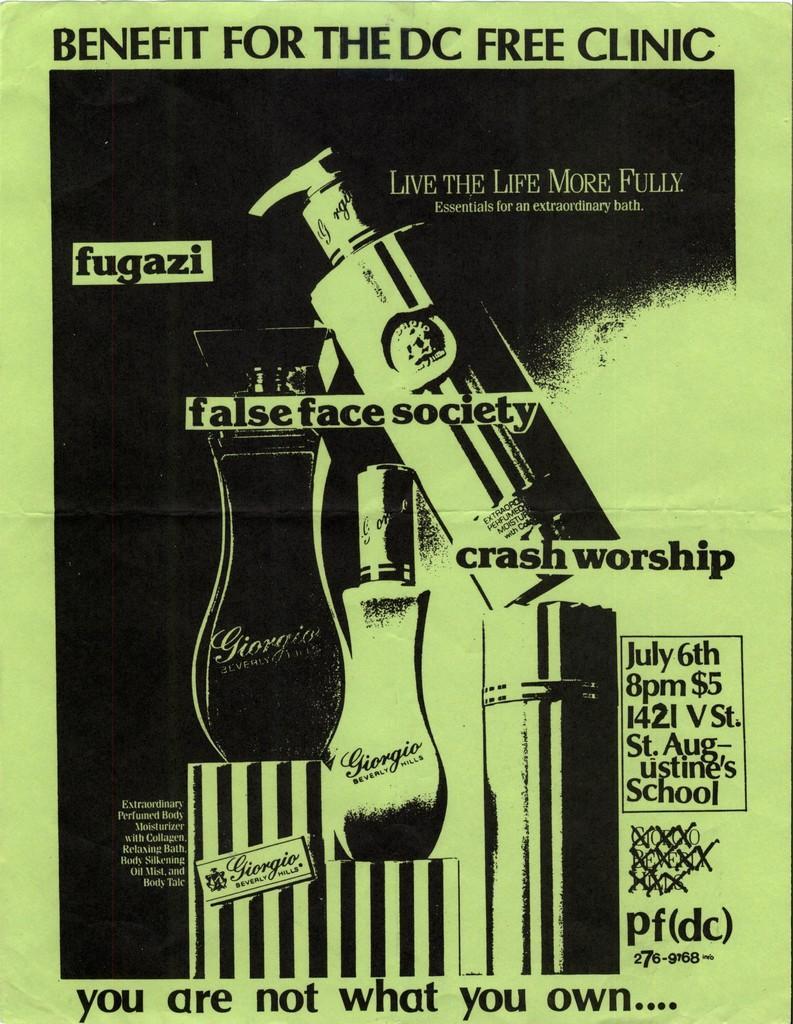How would you summarize this image in a sentence or two? In this image I can see there are bottles with the text in black and white color. 